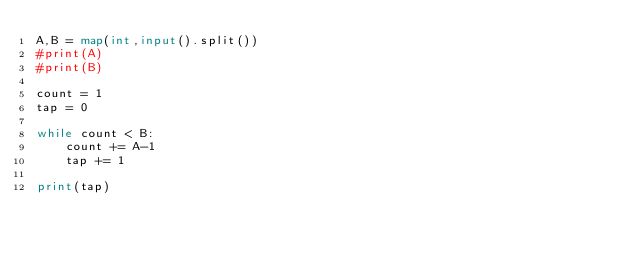<code> <loc_0><loc_0><loc_500><loc_500><_Python_>A,B = map(int,input().split())
#print(A)
#print(B)

count = 1
tap = 0

while count < B:
    count += A-1
    tap += 1

print(tap)
</code> 